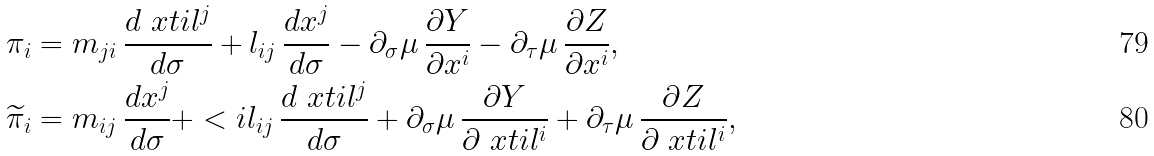Convert formula to latex. <formula><loc_0><loc_0><loc_500><loc_500>\pi _ { i } & = m _ { j i } \, \frac { d \ x t i l ^ { j } } { d \sigma } + l _ { i j } \, \frac { d x ^ { j } } { d \sigma } - \partial _ { \sigma } \mu \, \frac { \partial Y } { \partial x ^ { i } } - \partial _ { \tau } \mu \, \frac { \partial Z } { \partial x ^ { i } } , \\ \widetilde { \pi } _ { i } & = m _ { i j } \, \frac { d x ^ { j } } { d \sigma } + < i l _ { i j } \, \frac { d \ x t i l ^ { j } } { d \sigma } + \partial _ { \sigma } \mu \, \frac { \partial Y } { \partial \ x t i l ^ { i } } + \partial _ { \tau } \mu \, \frac { \partial Z } { \partial \ x t i l ^ { i } } ,</formula> 